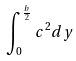Convert formula to latex. <formula><loc_0><loc_0><loc_500><loc_500>\int _ { 0 } ^ { \frac { b } { 2 } } c ^ { 2 } d y</formula> 